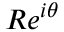Convert formula to latex. <formula><loc_0><loc_0><loc_500><loc_500>R e ^ { i \theta }</formula> 